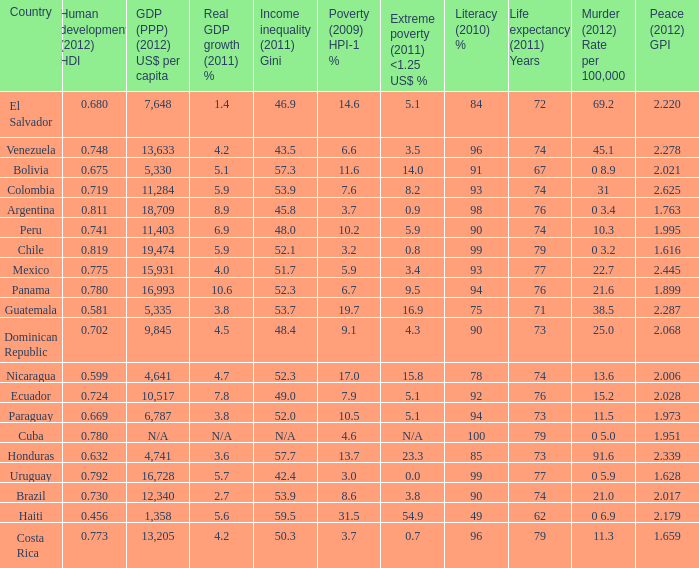What is the total poverty (2009) HPI-1 % when the extreme poverty (2011) <1.25 US$ % of 16.9, and the human development (2012) HDI is less than 0.581? None. 